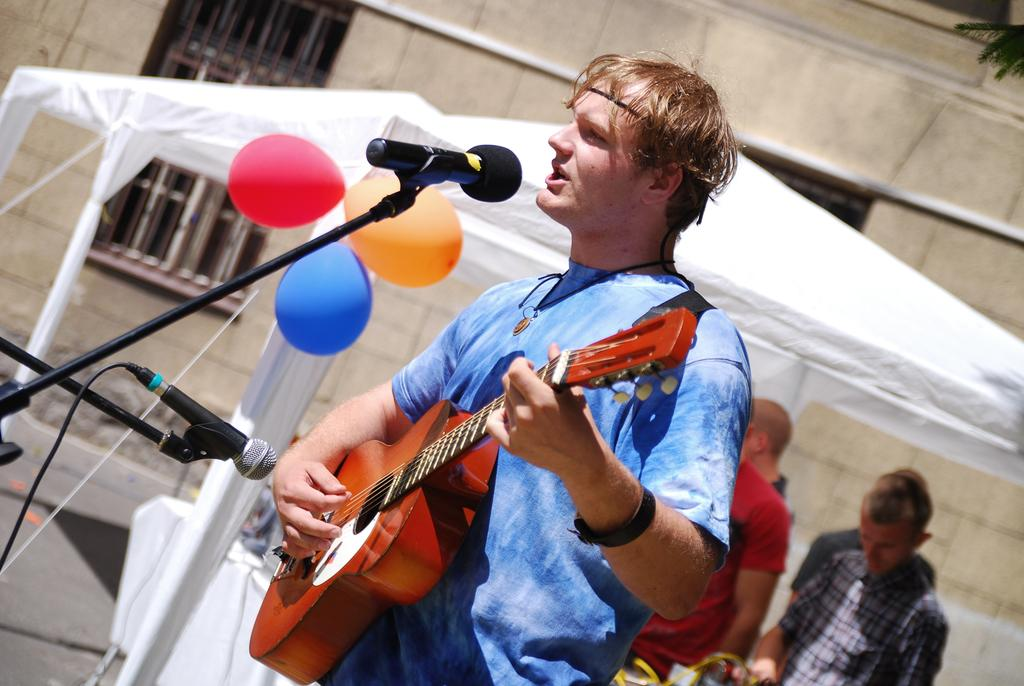What is the man in the image doing? The man is playing a guitar and singing in the image. How is the man amplifying his voice while singing? The man is using a microphone while singing. What decorations can be seen in the image? There are balloons in the image. What type of shelter is visible in the image? There is a tent in the image. Can you describe the people in the background of the image? There are people standing in the background of the image. What invention is the man using to create orange juice in the image? There is no invention for creating orange juice present in the image. 